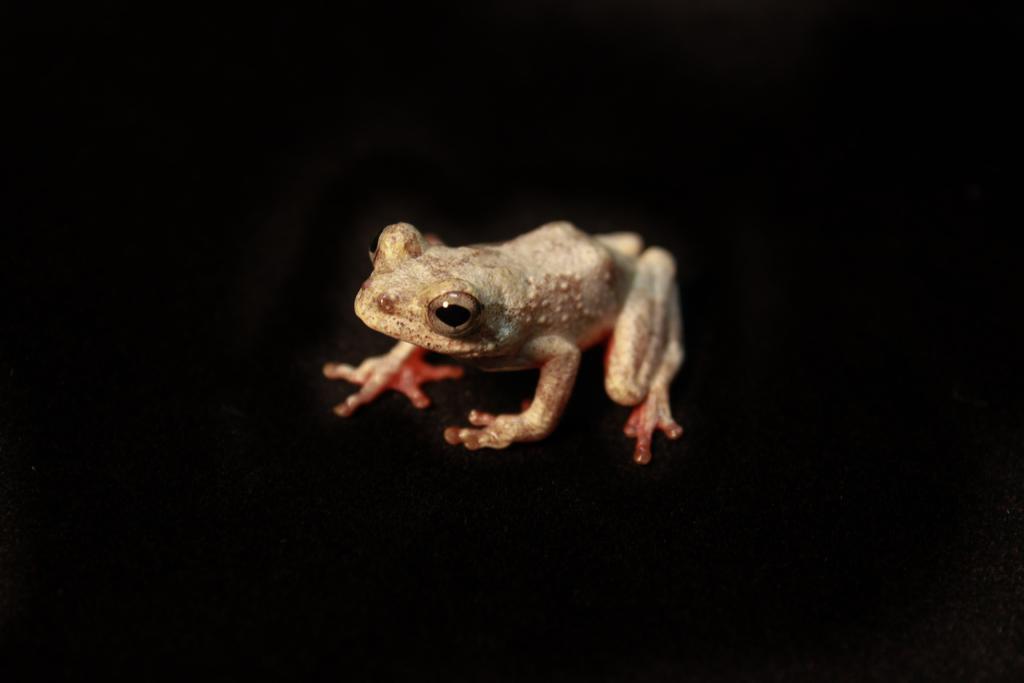Can you describe this image briefly? In this image I can see a frog which is orange, black, cream and brown in color. I can see the black colored background. 